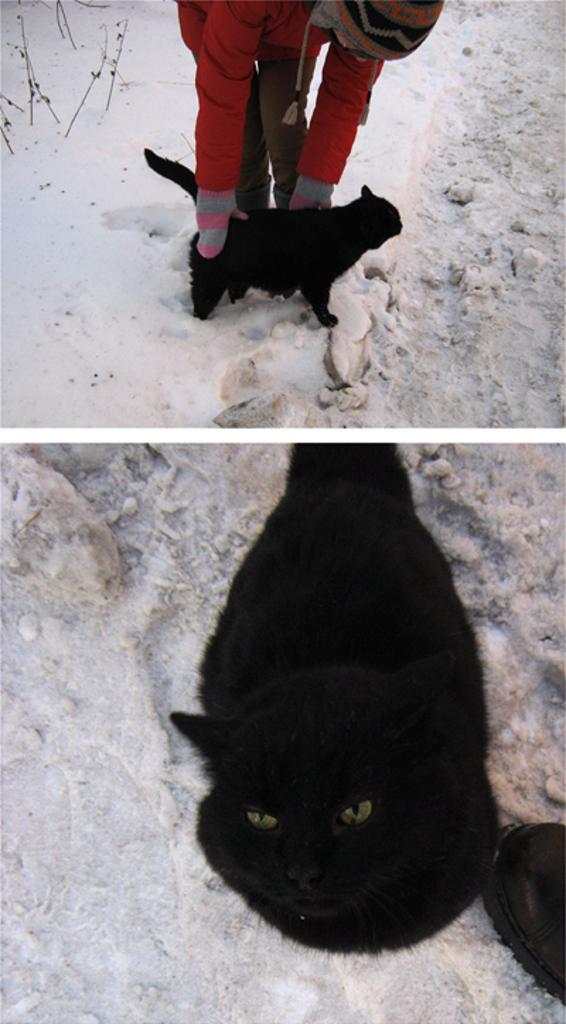Describe this image in one or two sentences. This is an image with collage. In that a person is holding a cat and the second image shows the cat lying down. 